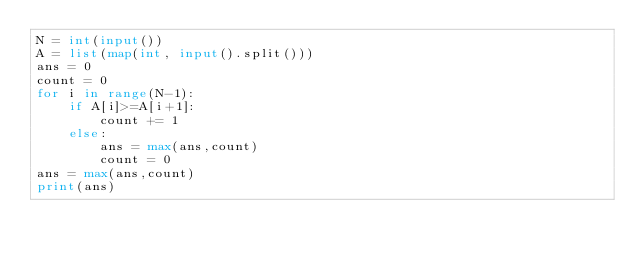<code> <loc_0><loc_0><loc_500><loc_500><_Python_>N = int(input())
A = list(map(int, input().split()))
ans = 0
count = 0
for i in range(N-1):
    if A[i]>=A[i+1]:
        count += 1
    else:
        ans = max(ans,count)
        count = 0
ans = max(ans,count)
print(ans)</code> 